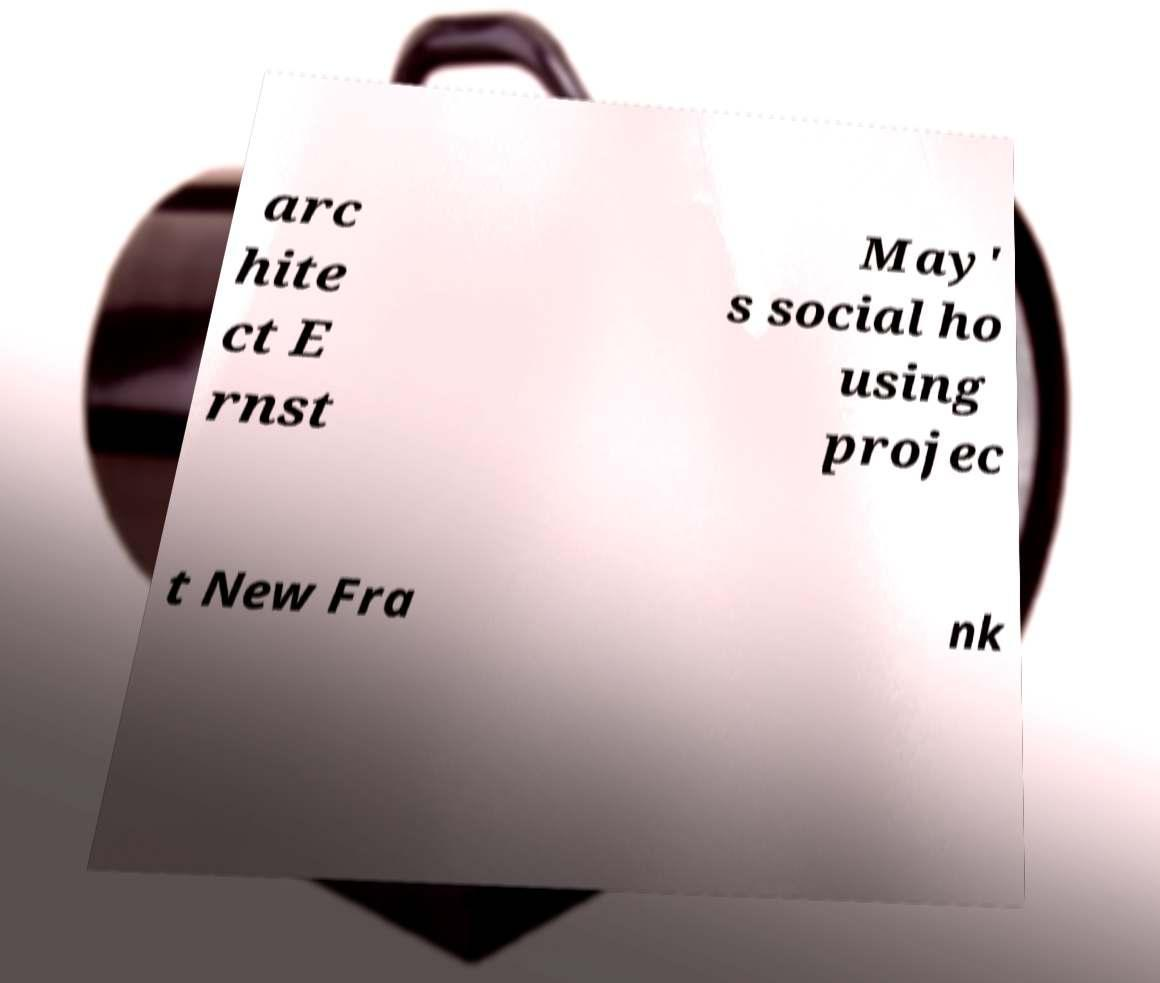Can you accurately transcribe the text from the provided image for me? arc hite ct E rnst May' s social ho using projec t New Fra nk 